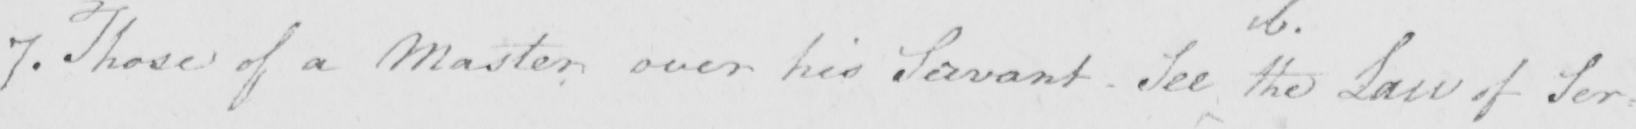Please transcribe the handwritten text in this image. 7 . Those of a Master over his Servant - See the Law of Ser 